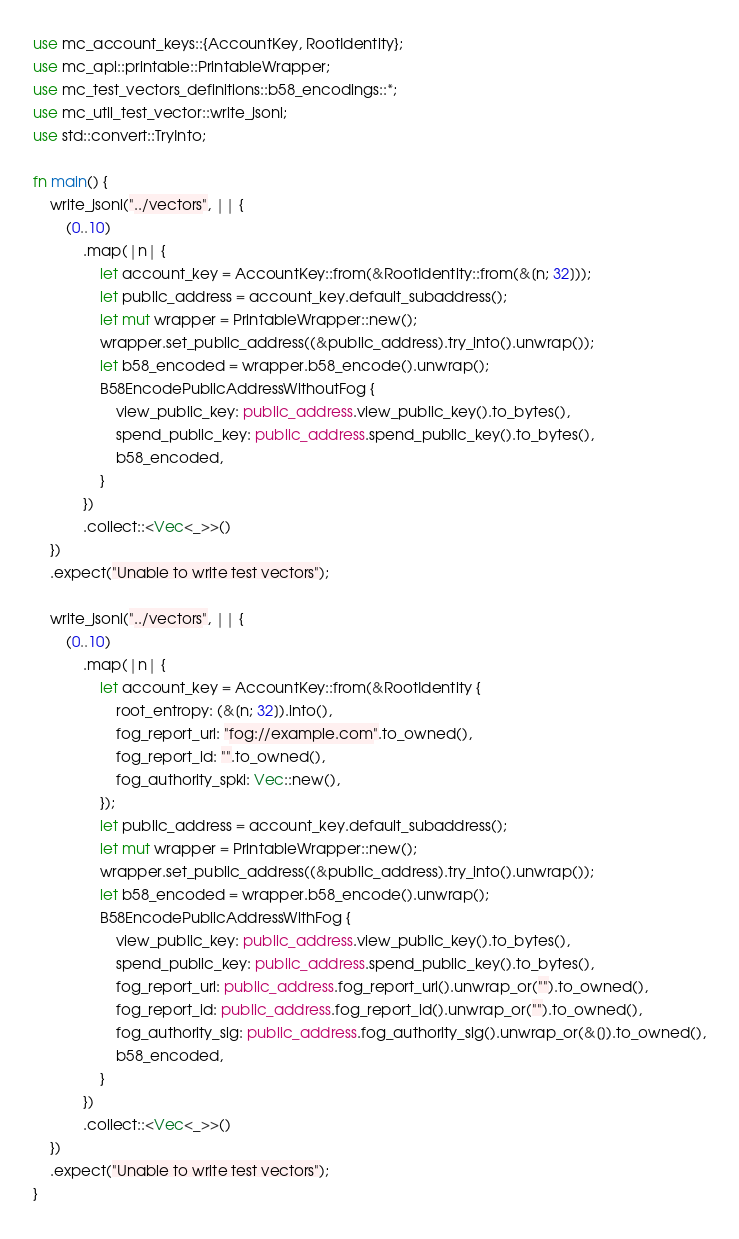Convert code to text. <code><loc_0><loc_0><loc_500><loc_500><_Rust_>use mc_account_keys::{AccountKey, RootIdentity};
use mc_api::printable::PrintableWrapper;
use mc_test_vectors_definitions::b58_encodings::*;
use mc_util_test_vector::write_jsonl;
use std::convert::TryInto;

fn main() {
    write_jsonl("../vectors", || {
        (0..10)
            .map(|n| {
                let account_key = AccountKey::from(&RootIdentity::from(&[n; 32]));
                let public_address = account_key.default_subaddress();
                let mut wrapper = PrintableWrapper::new();
                wrapper.set_public_address((&public_address).try_into().unwrap());
                let b58_encoded = wrapper.b58_encode().unwrap();
                B58EncodePublicAddressWithoutFog {
                    view_public_key: public_address.view_public_key().to_bytes(),
                    spend_public_key: public_address.spend_public_key().to_bytes(),
                    b58_encoded,
                }
            })
            .collect::<Vec<_>>()
    })
    .expect("Unable to write test vectors");

    write_jsonl("../vectors", || {
        (0..10)
            .map(|n| {
                let account_key = AccountKey::from(&RootIdentity {
                    root_entropy: (&[n; 32]).into(),
                    fog_report_url: "fog://example.com".to_owned(),
                    fog_report_id: "".to_owned(),
                    fog_authority_spki: Vec::new(),
                });
                let public_address = account_key.default_subaddress();
                let mut wrapper = PrintableWrapper::new();
                wrapper.set_public_address((&public_address).try_into().unwrap());
                let b58_encoded = wrapper.b58_encode().unwrap();
                B58EncodePublicAddressWithFog {
                    view_public_key: public_address.view_public_key().to_bytes(),
                    spend_public_key: public_address.spend_public_key().to_bytes(),
                    fog_report_url: public_address.fog_report_url().unwrap_or("").to_owned(),
                    fog_report_id: public_address.fog_report_id().unwrap_or("").to_owned(),
                    fog_authority_sig: public_address.fog_authority_sig().unwrap_or(&[]).to_owned(),
                    b58_encoded,
                }
            })
            .collect::<Vec<_>>()
    })
    .expect("Unable to write test vectors");
}
</code> 